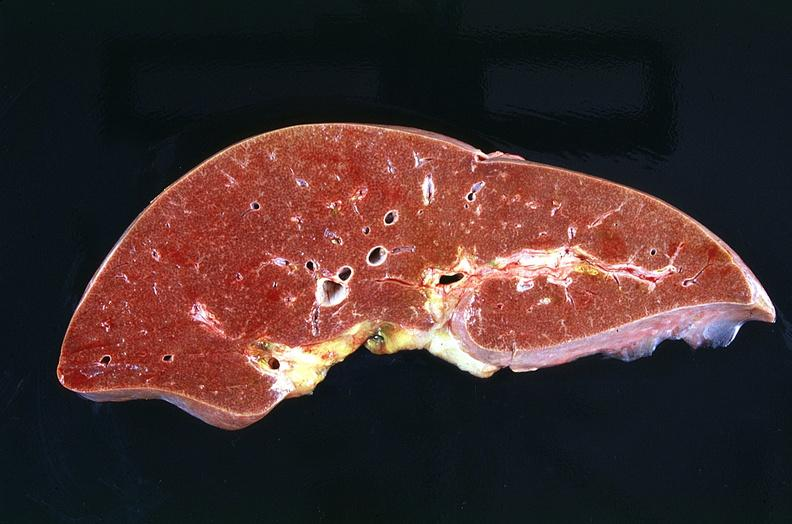s gangrene present?
Answer the question using a single word or phrase. No 